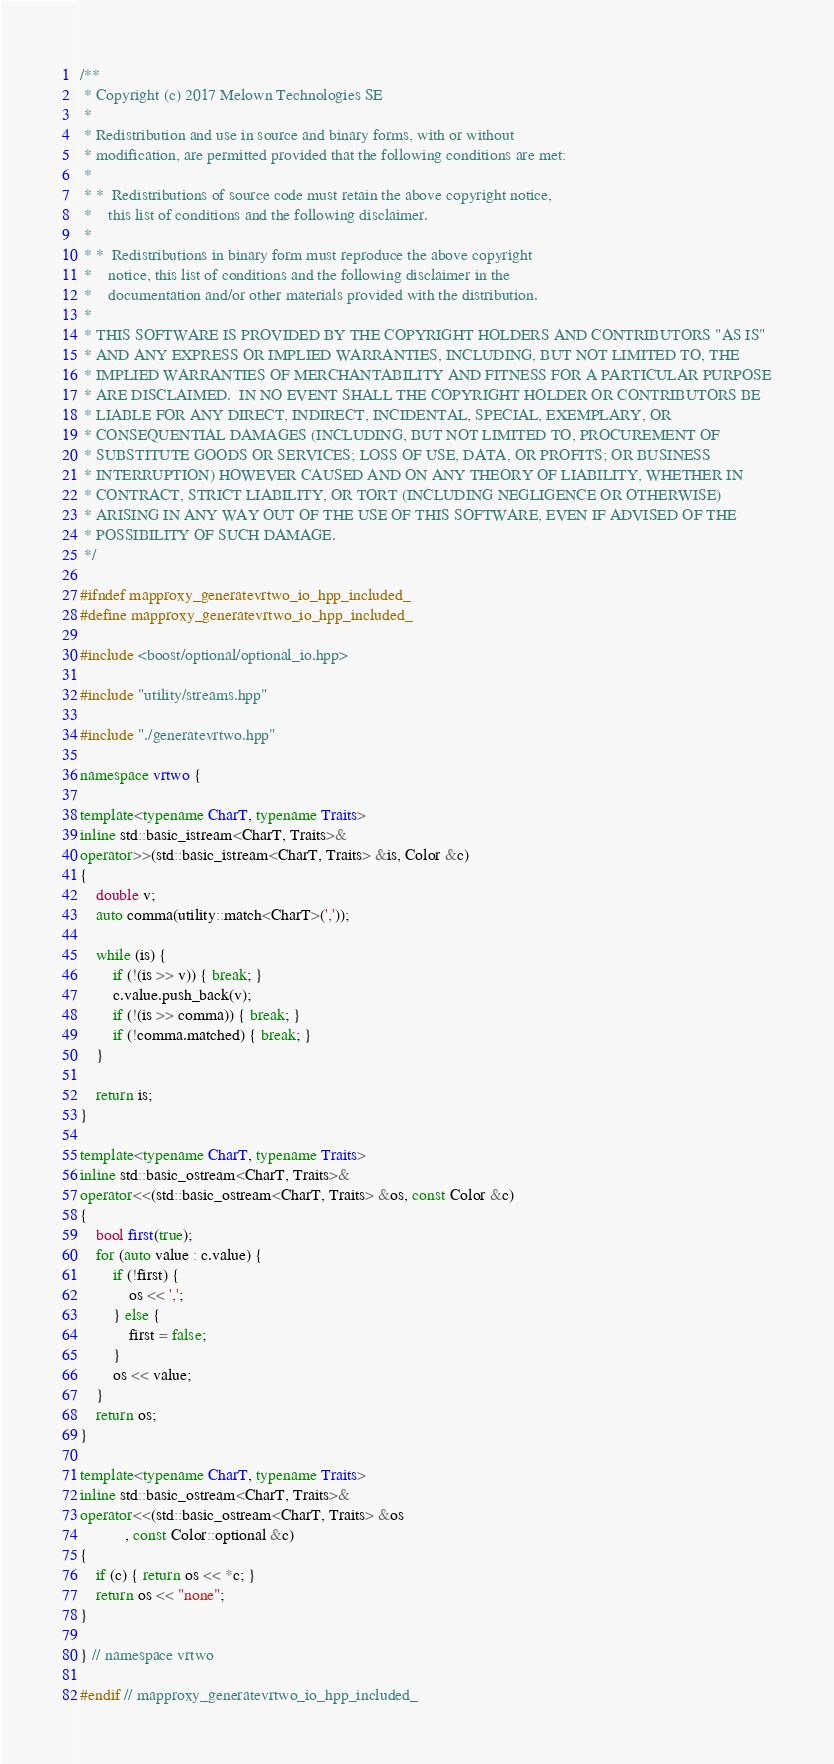<code> <loc_0><loc_0><loc_500><loc_500><_C++_>/**
 * Copyright (c) 2017 Melown Technologies SE
 *
 * Redistribution and use in source and binary forms, with or without
 * modification, are permitted provided that the following conditions are met:
 *
 * *  Redistributions of source code must retain the above copyright notice,
 *    this list of conditions and the following disclaimer.
 *
 * *  Redistributions in binary form must reproduce the above copyright
 *    notice, this list of conditions and the following disclaimer in the
 *    documentation and/or other materials provided with the distribution.
 *
 * THIS SOFTWARE IS PROVIDED BY THE COPYRIGHT HOLDERS AND CONTRIBUTORS "AS IS"
 * AND ANY EXPRESS OR IMPLIED WARRANTIES, INCLUDING, BUT NOT LIMITED TO, THE
 * IMPLIED WARRANTIES OF MERCHANTABILITY AND FITNESS FOR A PARTICULAR PURPOSE
 * ARE DISCLAIMED.  IN NO EVENT SHALL THE COPYRIGHT HOLDER OR CONTRIBUTORS BE
 * LIABLE FOR ANY DIRECT, INDIRECT, INCIDENTAL, SPECIAL, EXEMPLARY, OR
 * CONSEQUENTIAL DAMAGES (INCLUDING, BUT NOT LIMITED TO, PROCUREMENT OF
 * SUBSTITUTE GOODS OR SERVICES; LOSS OF USE, DATA, OR PROFITS; OR BUSINESS
 * INTERRUPTION) HOWEVER CAUSED AND ON ANY THEORY OF LIABILITY, WHETHER IN
 * CONTRACT, STRICT LIABILITY, OR TORT (INCLUDING NEGLIGENCE OR OTHERWISE)
 * ARISING IN ANY WAY OUT OF THE USE OF THIS SOFTWARE, EVEN IF ADVISED OF THE
 * POSSIBILITY OF SUCH DAMAGE.
 */

#ifndef mapproxy_generatevrtwo_io_hpp_included_
#define mapproxy_generatevrtwo_io_hpp_included_

#include <boost/optional/optional_io.hpp>

#include "utility/streams.hpp"

#include "./generatevrtwo.hpp"

namespace vrtwo {

template<typename CharT, typename Traits>
inline std::basic_istream<CharT, Traits>&
operator>>(std::basic_istream<CharT, Traits> &is, Color &c)
{
    double v;
    auto comma(utility::match<CharT>(','));

    while (is) {
        if (!(is >> v)) { break; }
        c.value.push_back(v);
        if (!(is >> comma)) { break; }
        if (!comma.matched) { break; }
    }

    return is;
}

template<typename CharT, typename Traits>
inline std::basic_ostream<CharT, Traits>&
operator<<(std::basic_ostream<CharT, Traits> &os, const Color &c)
{
    bool first(true);
    for (auto value : c.value) {
        if (!first) {
            os << ',';
        } else {
            first = false;
        }
        os << value;
    }
    return os;
}

template<typename CharT, typename Traits>
inline std::basic_ostream<CharT, Traits>&
operator<<(std::basic_ostream<CharT, Traits> &os
           , const Color::optional &c)
{
    if (c) { return os << *c; }
    return os << "none";
}

} // namespace vrtwo

#endif // mapproxy_generatevrtwo_io_hpp_included_
</code> 